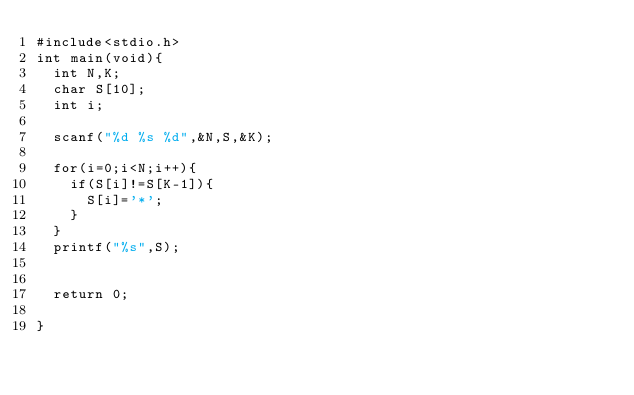<code> <loc_0><loc_0><loc_500><loc_500><_C_>#include<stdio.h>
int main(void){
	int N,K;
	char S[10];
	int i;
	
	scanf("%d %s %d",&N,S,&K);
	
	for(i=0;i<N;i++){
		if(S[i]!=S[K-1]){
			S[i]='*';
		}
	}
	printf("%s",S);
	

	return 0;
	
}







</code> 